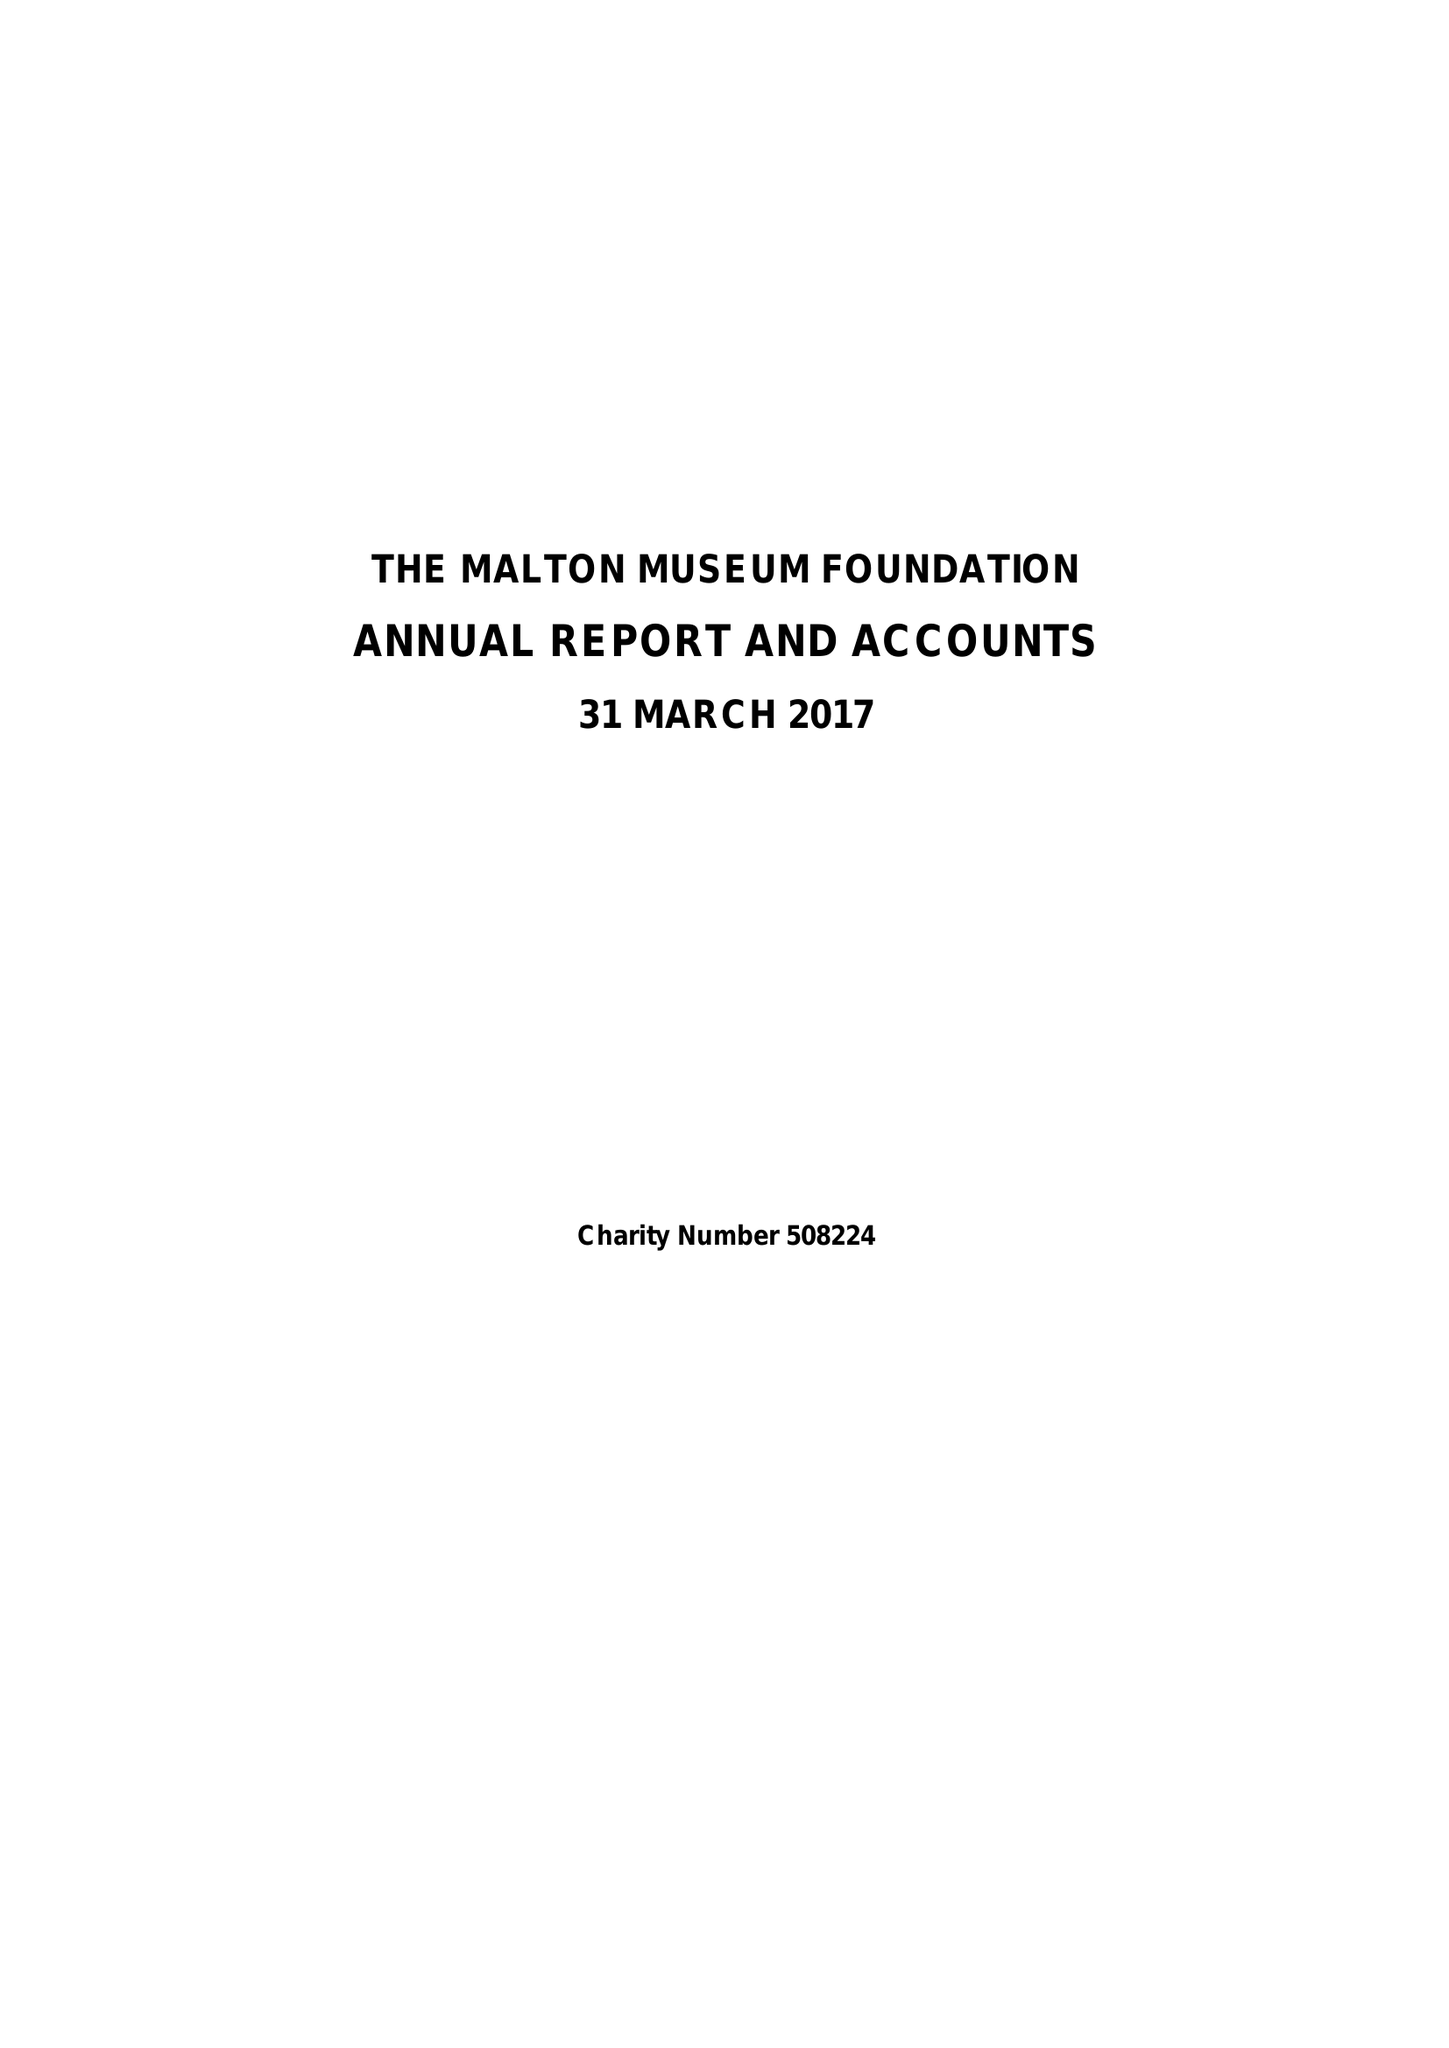What is the value for the charity_number?
Answer the question using a single word or phrase. 508224 